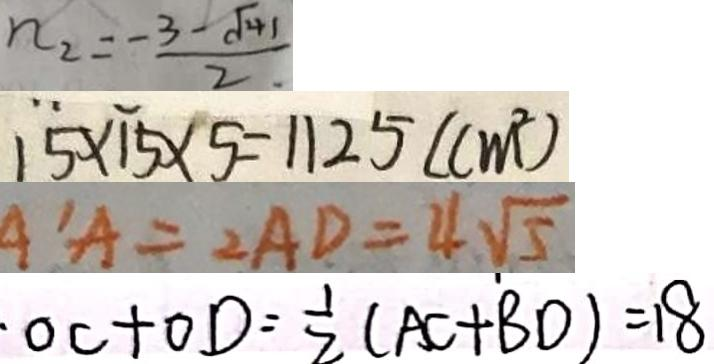Convert formula to latex. <formula><loc_0><loc_0><loc_500><loc_500>n _ { 2 } = \frac { - 3 - \sqrt { 4 1 } } { 2 } 
 1 5 \times 1 5 \times 5 = 1 1 2 5 ( c m ^ { 2 } ) 
 A ^ { \prime } A = 2 A D = 4 \sqrt { 5 } 
 \cdot O C + O D = \frac { 1 } { 2 } ( A C + B D ) = 1 8</formula> 